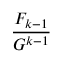<formula> <loc_0><loc_0><loc_500><loc_500>\frac { F _ { k - 1 } } { G ^ { k - 1 } }</formula> 